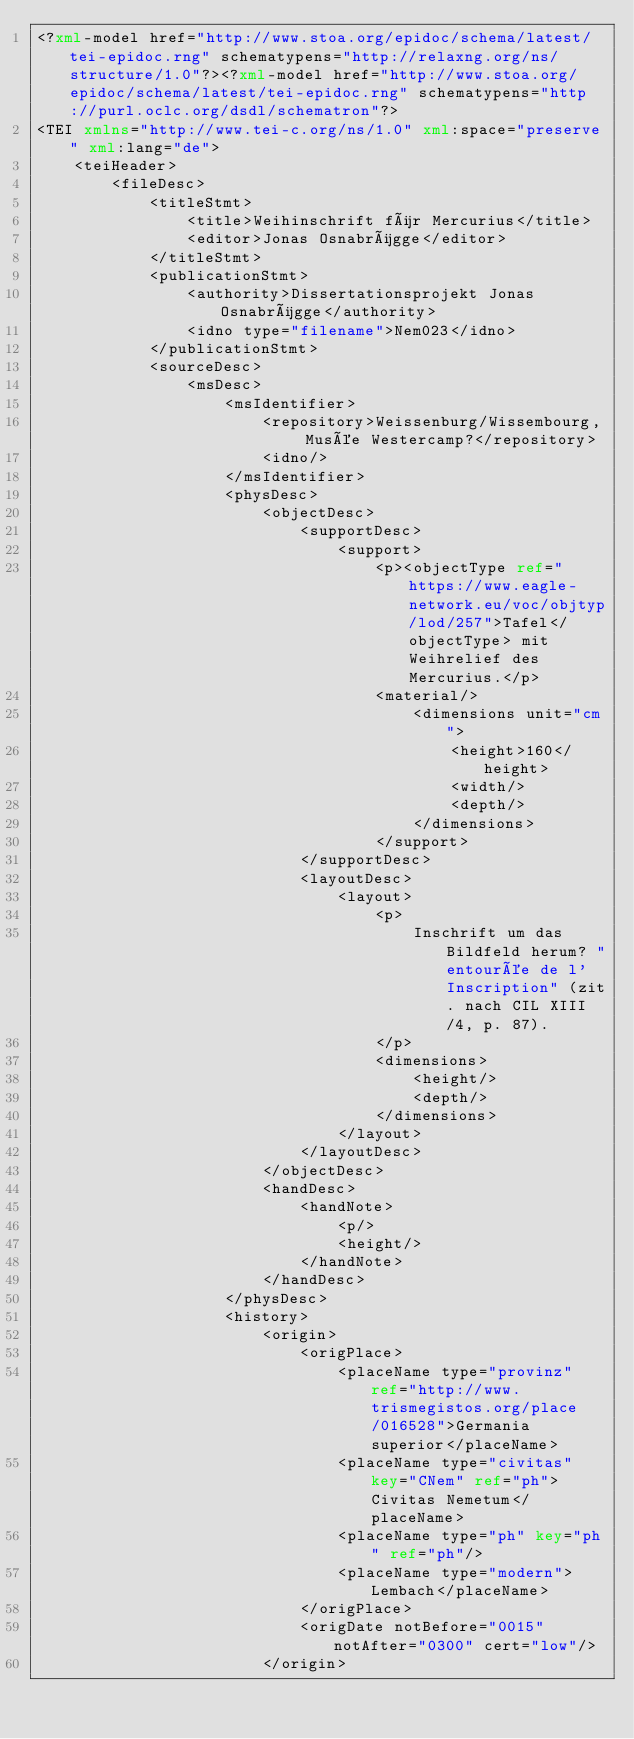Convert code to text. <code><loc_0><loc_0><loc_500><loc_500><_XML_><?xml-model href="http://www.stoa.org/epidoc/schema/latest/tei-epidoc.rng" schematypens="http://relaxng.org/ns/structure/1.0"?><?xml-model href="http://www.stoa.org/epidoc/schema/latest/tei-epidoc.rng" schematypens="http://purl.oclc.org/dsdl/schematron"?>
<TEI xmlns="http://www.tei-c.org/ns/1.0" xml:space="preserve" xml:lang="de">
    <teiHeader>
        <fileDesc>
            <titleStmt>
                <title>Weihinschrift für Mercurius</title>
                <editor>Jonas Osnabrügge</editor>
            </titleStmt>
            <publicationStmt>
                <authority>Dissertationsprojekt Jonas Osnabrügge</authority>
                <idno type="filename">Nem023</idno>
            </publicationStmt>
            <sourceDesc>
                <msDesc>
                    <msIdentifier>
                        <repository>Weissenburg/Wissembourg, Musée Westercamp?</repository>
                        <idno/>
                    </msIdentifier>
                    <physDesc>
                        <objectDesc>
                            <supportDesc>
                                <support>
                                    <p><objectType ref="https://www.eagle-network.eu/voc/objtyp/lod/257">Tafel</objectType> mit Weihrelief des Mercurius.</p>
                                    <material/>
                                        <dimensions unit="cm">
                                            <height>160</height>
                                            <width/>
                                            <depth/>
                                        </dimensions>
                                    </support>
                            </supportDesc>
                            <layoutDesc>
                                <layout>
                                    <p>
                                        Inschrift um das Bildfeld herum? "entourée de l'Inscription" (zit. nach CIL XIII/4, p. 87).
                                    </p>
                                    <dimensions>
                                        <height/>
                                        <depth/>
                                    </dimensions>
                                </layout>
                            </layoutDesc>
                        </objectDesc>
                        <handDesc>
                            <handNote>
                                <p/>
                                <height/>
                            </handNote>
                        </handDesc>
                    </physDesc>
                    <history>
                        <origin>
                            <origPlace>
                                <placeName type="provinz" ref="http://www.trismegistos.org/place/016528">Germania superior</placeName>
                                <placeName type="civitas" key="CNem" ref="ph">Civitas Nemetum</placeName>
                                <placeName type="ph" key="ph" ref="ph"/>
                                <placeName type="modern">Lembach</placeName> 
                            </origPlace>
                            <origDate notBefore="0015" notAfter="0300" cert="low"/>
                        </origin></code> 